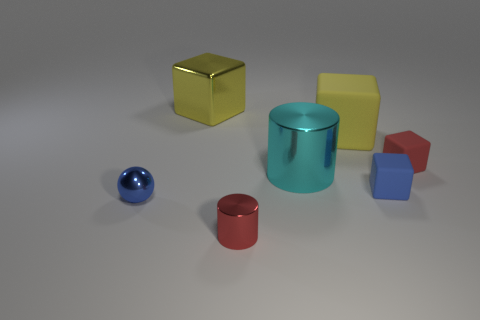Add 3 cyan metal balls. How many objects exist? 10 Subtract all brown blocks. Subtract all gray cylinders. How many blocks are left? 4 Subtract all cubes. How many objects are left? 3 Subtract all blue metallic spheres. Subtract all small purple metal blocks. How many objects are left? 6 Add 4 large matte cubes. How many large matte cubes are left? 5 Add 2 gray matte cylinders. How many gray matte cylinders exist? 2 Subtract 0 blue cylinders. How many objects are left? 7 